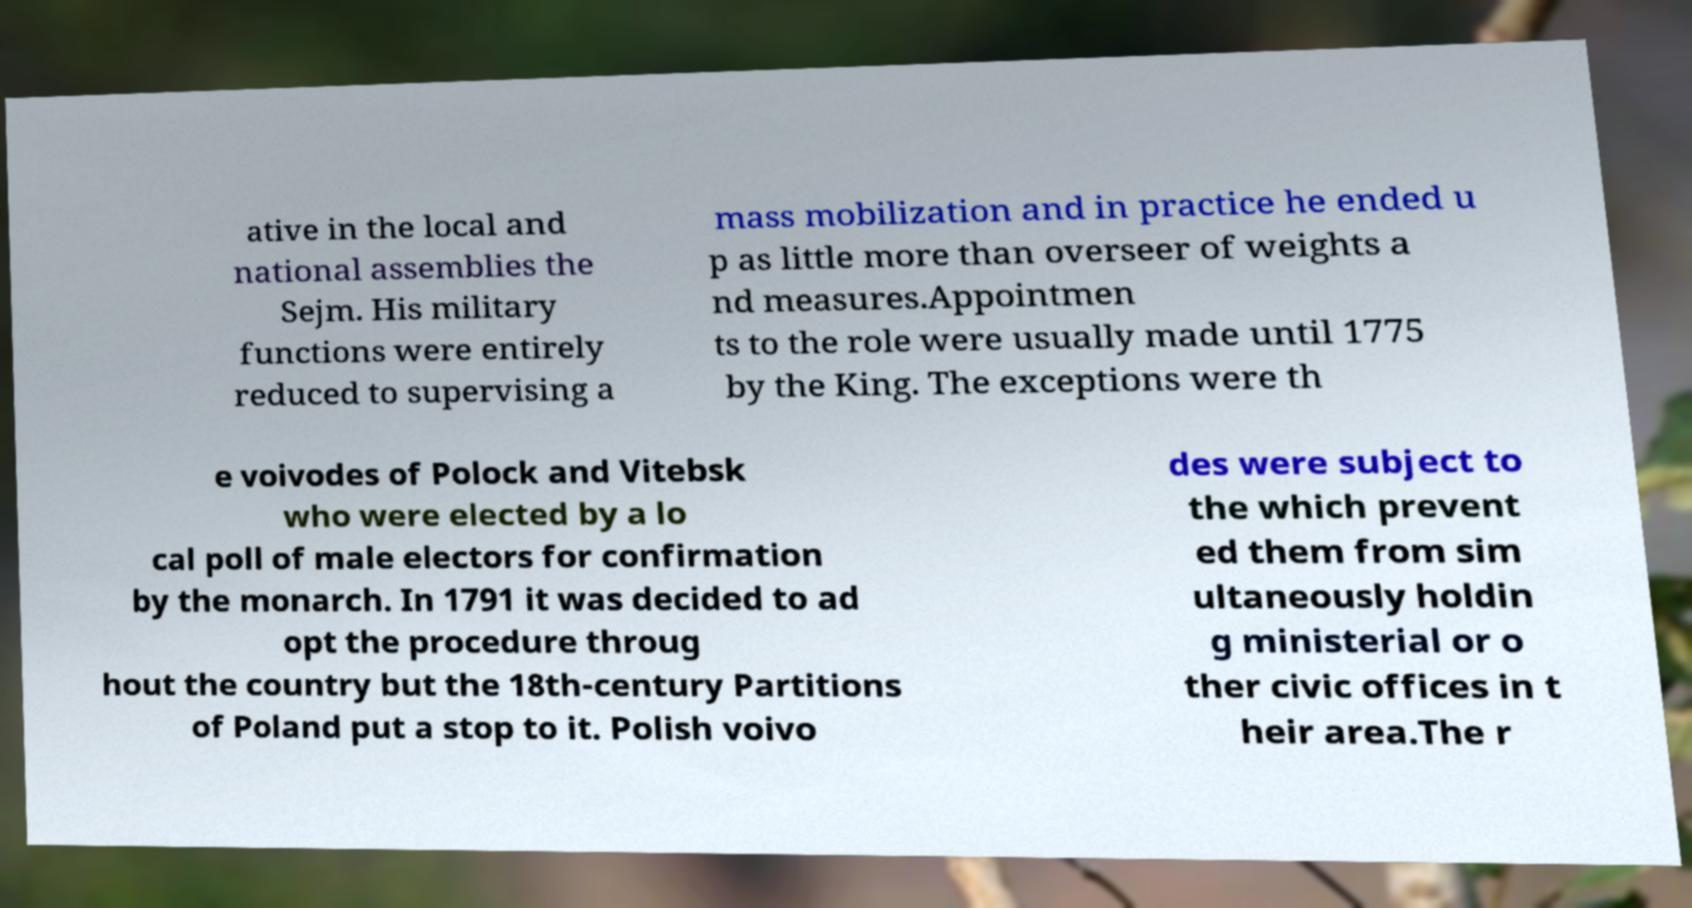Could you extract and type out the text from this image? ative in the local and national assemblies the Sejm. His military functions were entirely reduced to supervising a mass mobilization and in practice he ended u p as little more than overseer of weights a nd measures.Appointmen ts to the role were usually made until 1775 by the King. The exceptions were th e voivodes of Polock and Vitebsk who were elected by a lo cal poll of male electors for confirmation by the monarch. In 1791 it was decided to ad opt the procedure throug hout the country but the 18th-century Partitions of Poland put a stop to it. Polish voivo des were subject to the which prevent ed them from sim ultaneously holdin g ministerial or o ther civic offices in t heir area.The r 